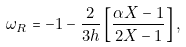Convert formula to latex. <formula><loc_0><loc_0><loc_500><loc_500>\omega _ { R } = - 1 - \frac { 2 } { 3 h } \left [ \frac { \alpha X - 1 } { 2 X - 1 } \right ] ,</formula> 